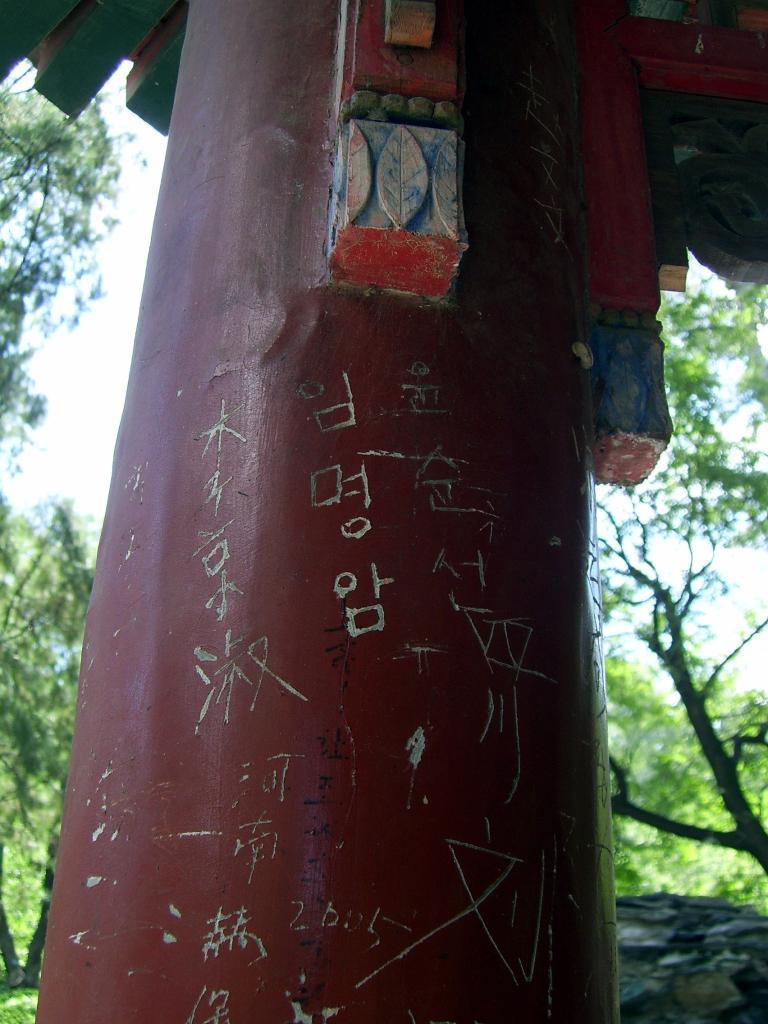Please provide a concise description of this image. In this picture we can see a pillar and behind the pillar there are trees and a sky. 